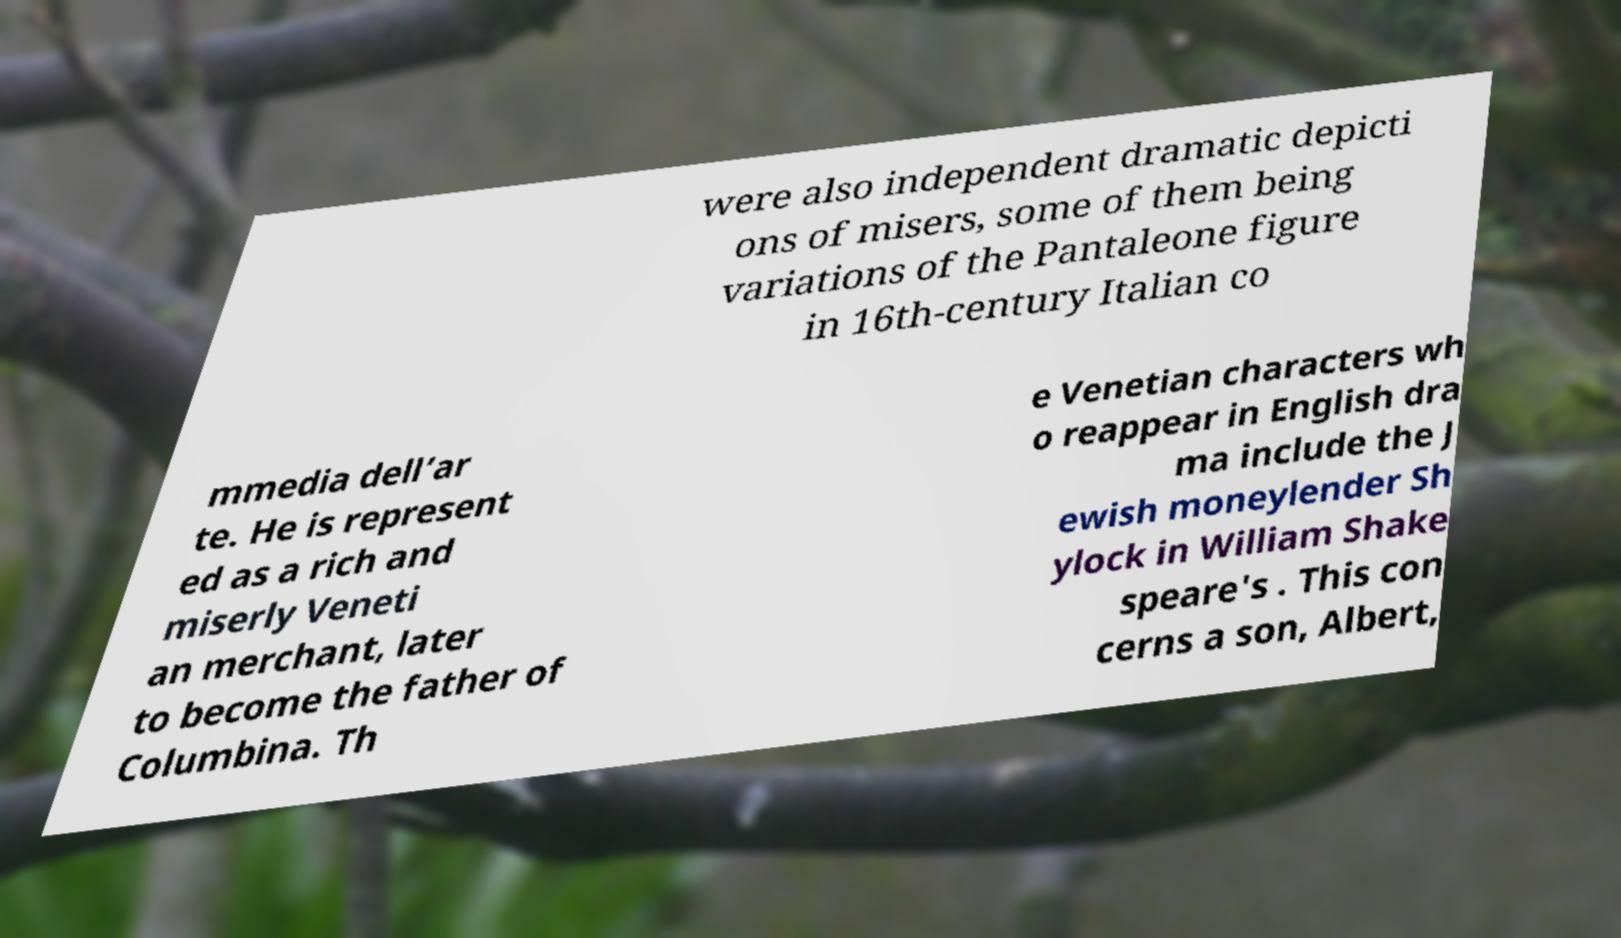Can you read and provide the text displayed in the image?This photo seems to have some interesting text. Can you extract and type it out for me? were also independent dramatic depicti ons of misers, some of them being variations of the Pantaleone figure in 16th-century Italian co mmedia dell’ar te. He is represent ed as a rich and miserly Veneti an merchant, later to become the father of Columbina. Th e Venetian characters wh o reappear in English dra ma include the J ewish moneylender Sh ylock in William Shake speare's . This con cerns a son, Albert, 